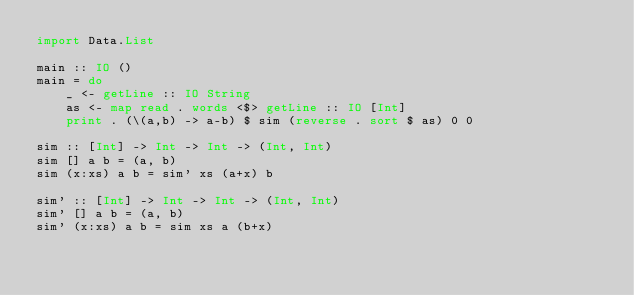Convert code to text. <code><loc_0><loc_0><loc_500><loc_500><_Haskell_>import Data.List

main :: IO ()
main = do
    _ <- getLine :: IO String
    as <- map read . words <$> getLine :: IO [Int]
    print . (\(a,b) -> a-b) $ sim (reverse . sort $ as) 0 0

sim :: [Int] -> Int -> Int -> (Int, Int)
sim [] a b = (a, b)
sim (x:xs) a b = sim' xs (a+x) b

sim' :: [Int] -> Int -> Int -> (Int, Int)
sim' [] a b = (a, b)
sim' (x:xs) a b = sim xs a (b+x)</code> 